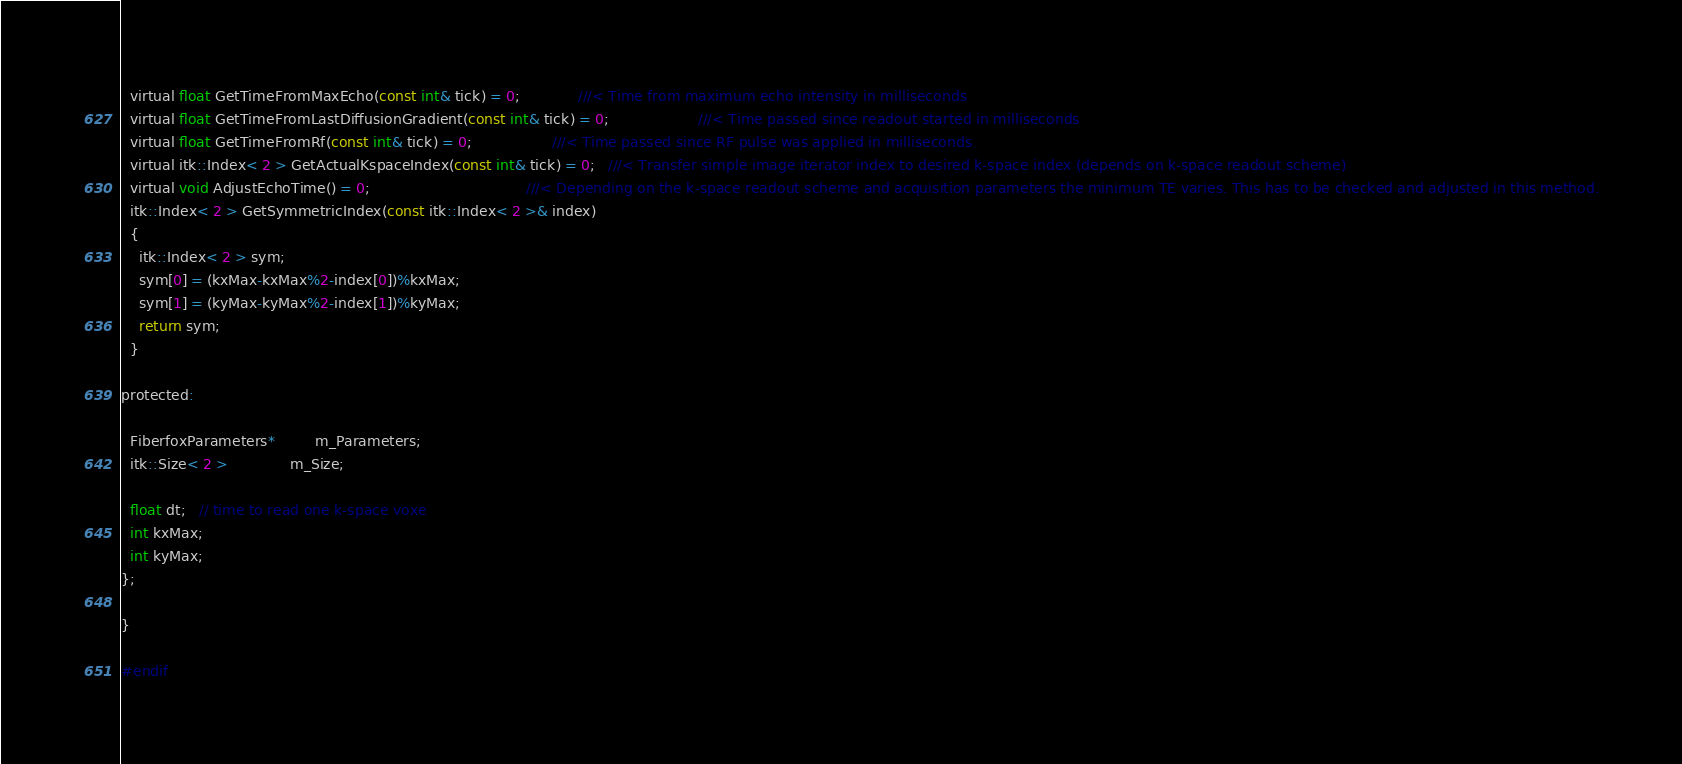<code> <loc_0><loc_0><loc_500><loc_500><_C_>  virtual float GetTimeFromMaxEcho(const int& tick) = 0;             ///< Time from maximum echo intensity in milliseconds
  virtual float GetTimeFromLastDiffusionGradient(const int& tick) = 0;                    ///< Time passed since readout started in milliseconds
  virtual float GetTimeFromRf(const int& tick) = 0;                  ///< Time passed since RF pulse was applied in milliseconds
  virtual itk::Index< 2 > GetActualKspaceIndex(const int& tick) = 0;   ///< Transfer simple image iterator index to desired k-space index (depends on k-space readout scheme)
  virtual void AdjustEchoTime() = 0;                                   ///< Depending on the k-space readout scheme and acquisition parameters the minimum TE varies. This has to be checked and adjusted in this method.
  itk::Index< 2 > GetSymmetricIndex(const itk::Index< 2 >& index)
  {
    itk::Index< 2 > sym;
    sym[0] = (kxMax-kxMax%2-index[0])%kxMax;
    sym[1] = (kyMax-kyMax%2-index[1])%kyMax;
    return sym;
  }

protected:

  FiberfoxParameters*         m_Parameters;
  itk::Size< 2 >              m_Size;

  float dt;   // time to read one k-space voxe
  int kxMax;
  int kyMax;
};

}

#endif

</code> 